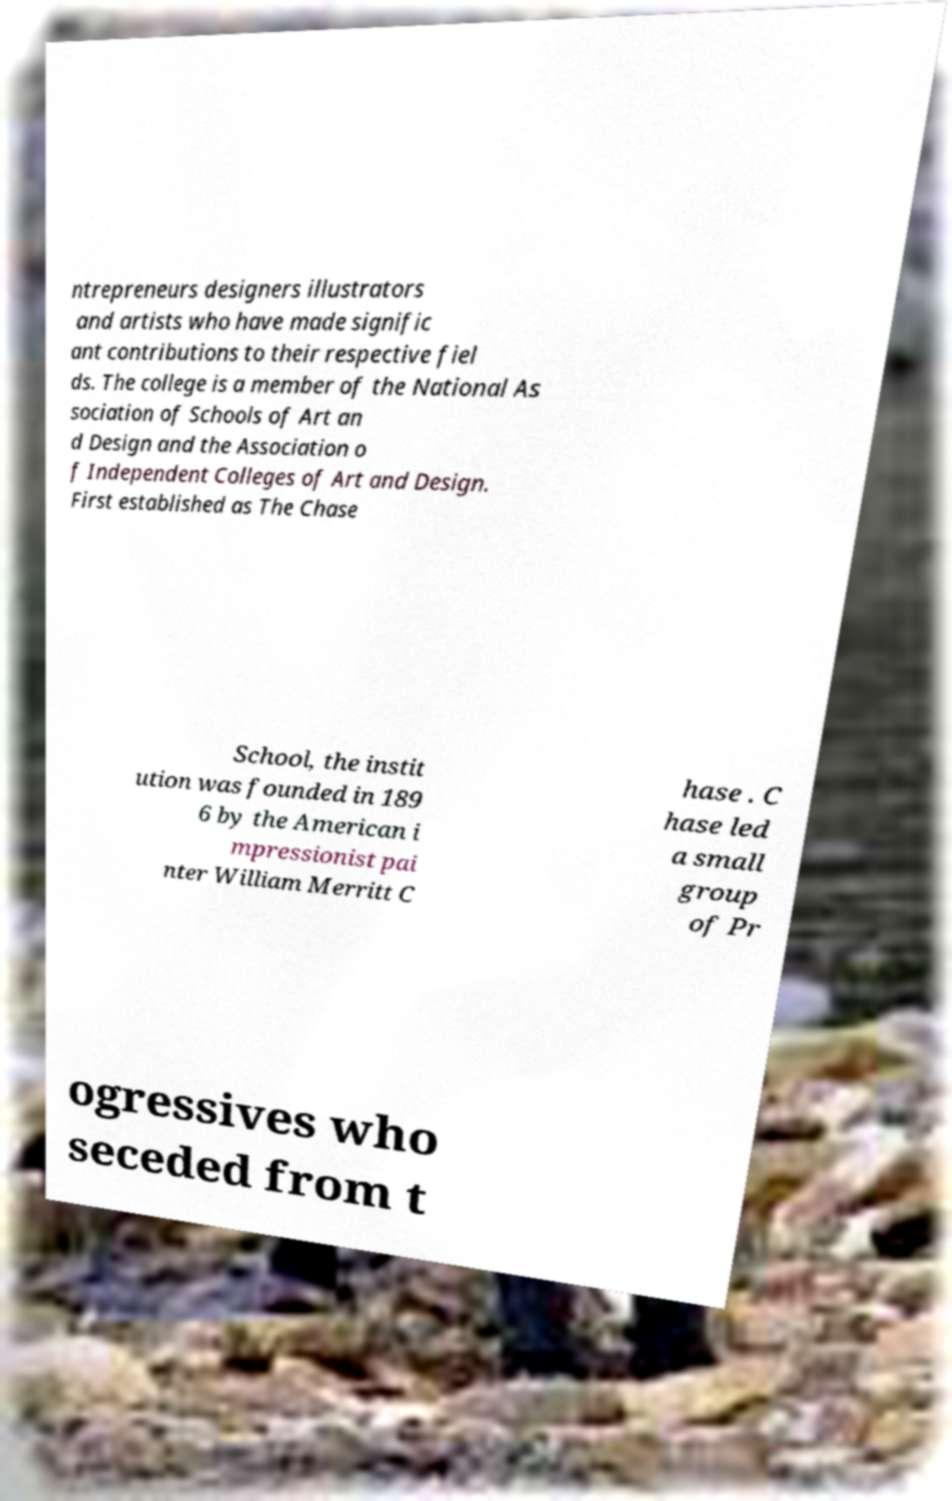What messages or text are displayed in this image? I need them in a readable, typed format. ntrepreneurs designers illustrators and artists who have made signific ant contributions to their respective fiel ds. The college is a member of the National As sociation of Schools of Art an d Design and the Association o f Independent Colleges of Art and Design. First established as The Chase School, the instit ution was founded in 189 6 by the American i mpressionist pai nter William Merritt C hase . C hase led a small group of Pr ogressives who seceded from t 